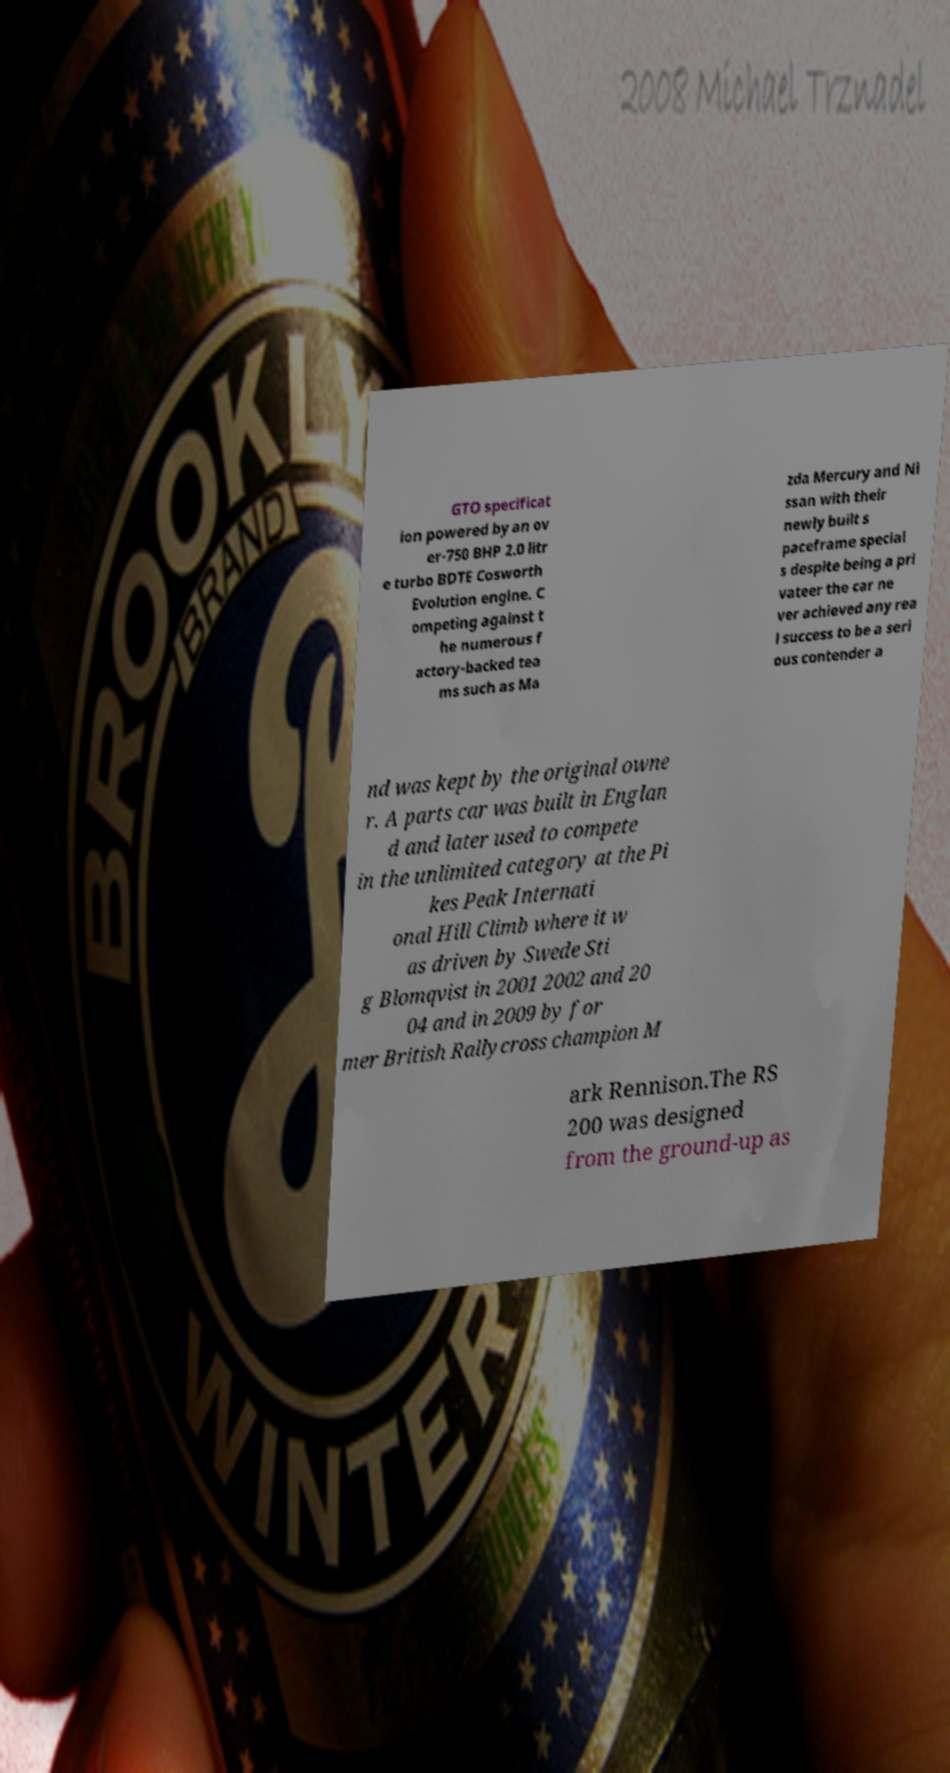There's text embedded in this image that I need extracted. Can you transcribe it verbatim? GTO specificat ion powered by an ov er-750 BHP 2.0 litr e turbo BDTE Cosworth Evolution engine. C ompeting against t he numerous f actory-backed tea ms such as Ma zda Mercury and Ni ssan with their newly built s paceframe special s despite being a pri vateer the car ne ver achieved any rea l success to be a seri ous contender a nd was kept by the original owne r. A parts car was built in Englan d and later used to compete in the unlimited category at the Pi kes Peak Internati onal Hill Climb where it w as driven by Swede Sti g Blomqvist in 2001 2002 and 20 04 and in 2009 by for mer British Rallycross champion M ark Rennison.The RS 200 was designed from the ground-up as 